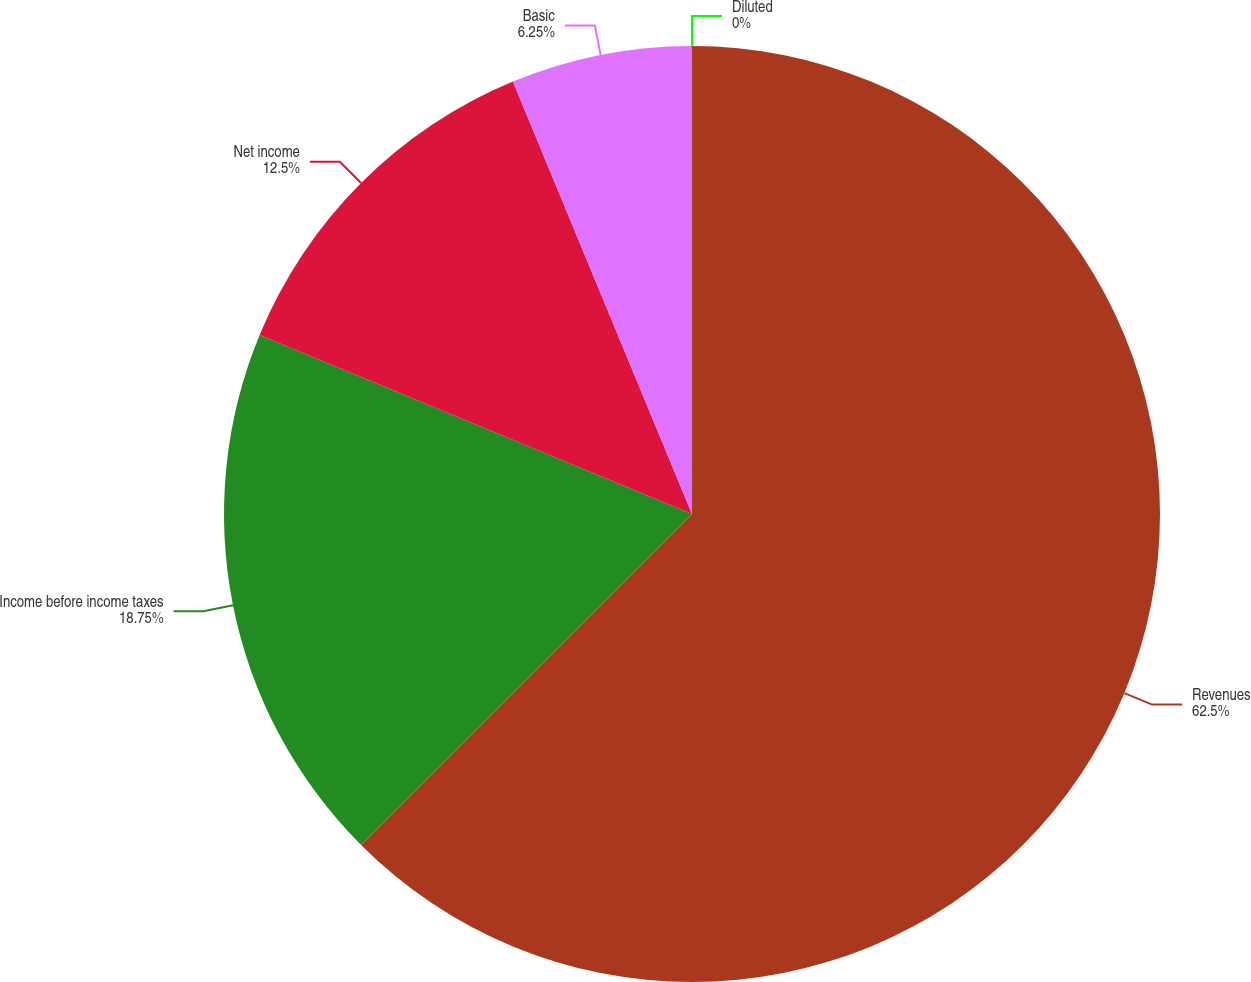Convert chart to OTSL. <chart><loc_0><loc_0><loc_500><loc_500><pie_chart><fcel>Revenues<fcel>Income before income taxes<fcel>Net income<fcel>Basic<fcel>Diluted<nl><fcel>62.5%<fcel>18.75%<fcel>12.5%<fcel>6.25%<fcel>0.0%<nl></chart> 